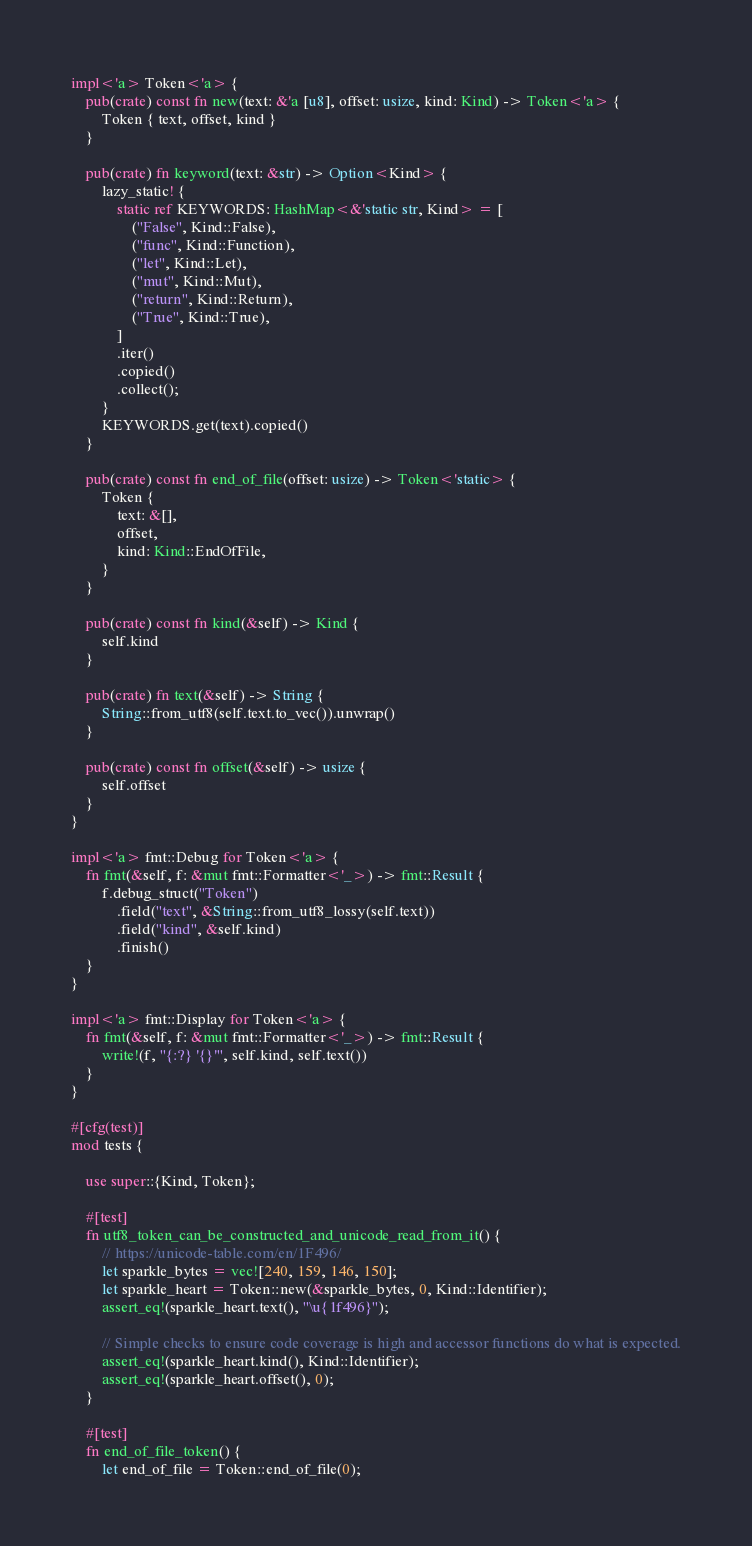<code> <loc_0><loc_0><loc_500><loc_500><_Rust_>
impl<'a> Token<'a> {
    pub(crate) const fn new(text: &'a [u8], offset: usize, kind: Kind) -> Token<'a> {
        Token { text, offset, kind }
    }

    pub(crate) fn keyword(text: &str) -> Option<Kind> {
        lazy_static! {
            static ref KEYWORDS: HashMap<&'static str, Kind> = [
                ("False", Kind::False),
                ("func", Kind::Function),
                ("let", Kind::Let),
                ("mut", Kind::Mut),
                ("return", Kind::Return),
                ("True", Kind::True),
            ]
            .iter()
            .copied()
            .collect();
        }
        KEYWORDS.get(text).copied()
    }

    pub(crate) const fn end_of_file(offset: usize) -> Token<'static> {
        Token {
            text: &[],
            offset,
            kind: Kind::EndOfFile,
        }
    }

    pub(crate) const fn kind(&self) -> Kind {
        self.kind
    }

    pub(crate) fn text(&self) -> String {
        String::from_utf8(self.text.to_vec()).unwrap()
    }

    pub(crate) const fn offset(&self) -> usize {
        self.offset
    }
}

impl<'a> fmt::Debug for Token<'a> {
    fn fmt(&self, f: &mut fmt::Formatter<'_>) -> fmt::Result {
        f.debug_struct("Token")
            .field("text", &String::from_utf8_lossy(self.text))
            .field("kind", &self.kind)
            .finish()
    }
}

impl<'a> fmt::Display for Token<'a> {
    fn fmt(&self, f: &mut fmt::Formatter<'_>) -> fmt::Result {
        write!(f, "{:?} '{}'", self.kind, self.text())
    }
}

#[cfg(test)]
mod tests {

    use super::{Kind, Token};

    #[test]
    fn utf8_token_can_be_constructed_and_unicode_read_from_it() {
        // https://unicode-table.com/en/1F496/
        let sparkle_bytes = vec![240, 159, 146, 150];
        let sparkle_heart = Token::new(&sparkle_bytes, 0, Kind::Identifier);
        assert_eq!(sparkle_heart.text(), "\u{1f496}");

        // Simple checks to ensure code coverage is high and accessor functions do what is expected.
        assert_eq!(sparkle_heart.kind(), Kind::Identifier);
        assert_eq!(sparkle_heart.offset(), 0);
    }

    #[test]
    fn end_of_file_token() {
        let end_of_file = Token::end_of_file(0);</code> 